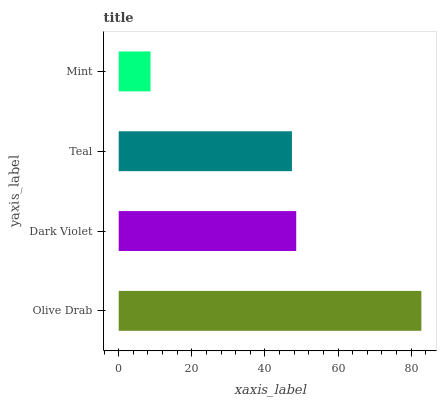Is Mint the minimum?
Answer yes or no. Yes. Is Olive Drab the maximum?
Answer yes or no. Yes. Is Dark Violet the minimum?
Answer yes or no. No. Is Dark Violet the maximum?
Answer yes or no. No. Is Olive Drab greater than Dark Violet?
Answer yes or no. Yes. Is Dark Violet less than Olive Drab?
Answer yes or no. Yes. Is Dark Violet greater than Olive Drab?
Answer yes or no. No. Is Olive Drab less than Dark Violet?
Answer yes or no. No. Is Dark Violet the high median?
Answer yes or no. Yes. Is Teal the low median?
Answer yes or no. Yes. Is Mint the high median?
Answer yes or no. No. Is Olive Drab the low median?
Answer yes or no. No. 